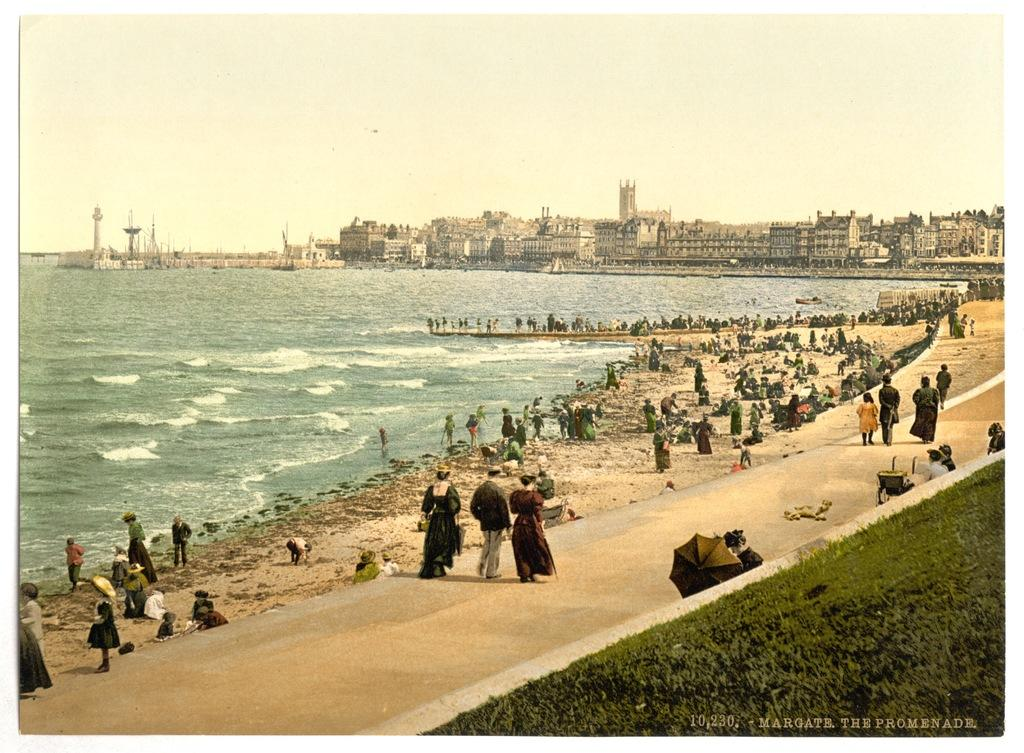What type of vegetation can be seen in the image? There is grass in the image. What structure is present in the image? There is a fence in the image. Where is the crowd located in the image? The crowd is on the beach in the image. What can be seen in the background of the image? Water, boats, buildings, and the sky are visible in the background of the image. What might suggest the location of the image? The image is likely taken near the ocean, as there is water, boats, and a beach present. How does the heat affect the body of the person in the image? There is no person present in the image, so it is not possible to determine how heat might affect their body. What is the starting point for the race in the image? There is no race present in the image, so it is not possible to determine a starting point. 